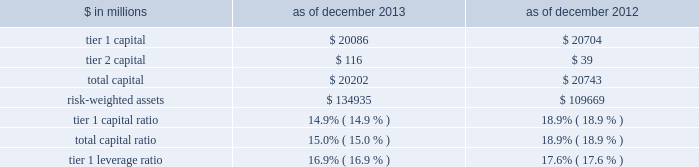Notes to consolidated financial statements under the regulatory framework for prompt corrective action applicable to gs bank usa , in order to meet the quantitative requirements for being a 201cwell-capitalized 201d depository institution , gs bank usa is required to maintain a tier 1 capital ratio of at least 6% ( 6 % ) , a total capital ratio of at least 10% ( 10 % ) and a tier 1 leverage ratio of at least 5% ( 5 % ) .
Gs bank usa agreed with the federal reserve board to maintain minimum capital ratios in excess of these 201cwell- capitalized 201d levels .
Accordingly , for a period of time , gs bank usa is expected to maintain a tier 1 capital ratio of at least 8% ( 8 % ) , a total capital ratio of at least 11% ( 11 % ) and a tier 1 leverage ratio of at least 6% ( 6 % ) .
As noted in the table below , gs bank usa was in compliance with these minimum capital requirements as of december 2013 and december 2012 .
The table below presents information regarding gs bank usa 2019s regulatory capital ratios under basel i , as implemented by the federal reserve board .
The information as of december 2013 reflects the revised market risk regulatory capital requirements , which became effective on january 1 , 2013 .
These changes resulted in increased regulatory capital requirements for market risk .
The information as of december 2012 is prior to the implementation of these revised market risk regulatory capital requirements. .
The revised capital framework described above is also applicable to gs bank usa , which is an advanced approach banking organization under this framework .
Gs bank usa has also been informed by the federal reserve board that it has completed a satisfactory parallel run , as required of advanced approach banking organizations under the revised capital framework , and therefore changes to its calculations of rwas will take effect beginning with the second quarter of 2014 .
Under the revised capital framework , as of january 1 , 2014 , gs bank usa became subject to a new minimum cet1 ratio requirement of 4% ( 4 % ) , increasing to 4.5% ( 4.5 % ) in 2015 .
In addition , the revised capital framework changes the standards for 201cwell-capitalized 201d status under prompt corrective action regulations beginning january 1 , 2015 by , among other things , introducing a cet1 ratio requirement of 6.5% ( 6.5 % ) and increasing the tier 1 capital ratio requirement from 6% ( 6 % ) to 8% ( 8 % ) .
In addition , commencing january 1 , 2018 , advanced approach banking organizations must have a supplementary leverage ratio of 3% ( 3 % ) or greater .
The basel committee published its final guidelines for calculating incremental capital requirements for domestic systemically important banking institutions ( d-sibs ) .
These guidelines are complementary to the framework outlined above for g-sibs .
The impact of these guidelines on the regulatory capital requirements of gs bank usa will depend on how they are implemented by the banking regulators in the united states .
The deposits of gs bank usa are insured by the fdic to the extent provided by law .
The federal reserve board requires depository institutions to maintain cash reserves with a federal reserve bank .
The amount deposited by the firm 2019s depository institution held at the federal reserve bank was approximately $ 50.39 billion and $ 58.67 billion as of december 2013 and december 2012 , respectively , which exceeded required reserve amounts by $ 50.29 billion and $ 58.59 billion as of december 2013 and december 2012 , respectively .
Transactions between gs bank usa and its subsidiaries and group inc .
And its subsidiaries and affiliates ( other than , generally , subsidiaries of gs bank usa ) are regulated by the federal reserve board .
These regulations generally limit the types and amounts of transactions ( including credit extensions from gs bank usa ) that may take place and generally require those transactions to be on market terms or better to gs bank usa .
The firm 2019s principal non-u.s .
Bank subsidiary , gsib , is a wholly-owned credit institution , regulated by the prudential regulation authority ( pra ) and the financial conduct authority ( fca ) and is subject to minimum capital requirements .
As of december 2013 and december 2012 , gsib was in compliance with all regulatory capital requirements .
Goldman sachs 2013 annual report 193 .
In millions , what was the change between 2013 and 2012 in tier 1 capital? 
Computations: (20086 - 20704)
Answer: -618.0. 